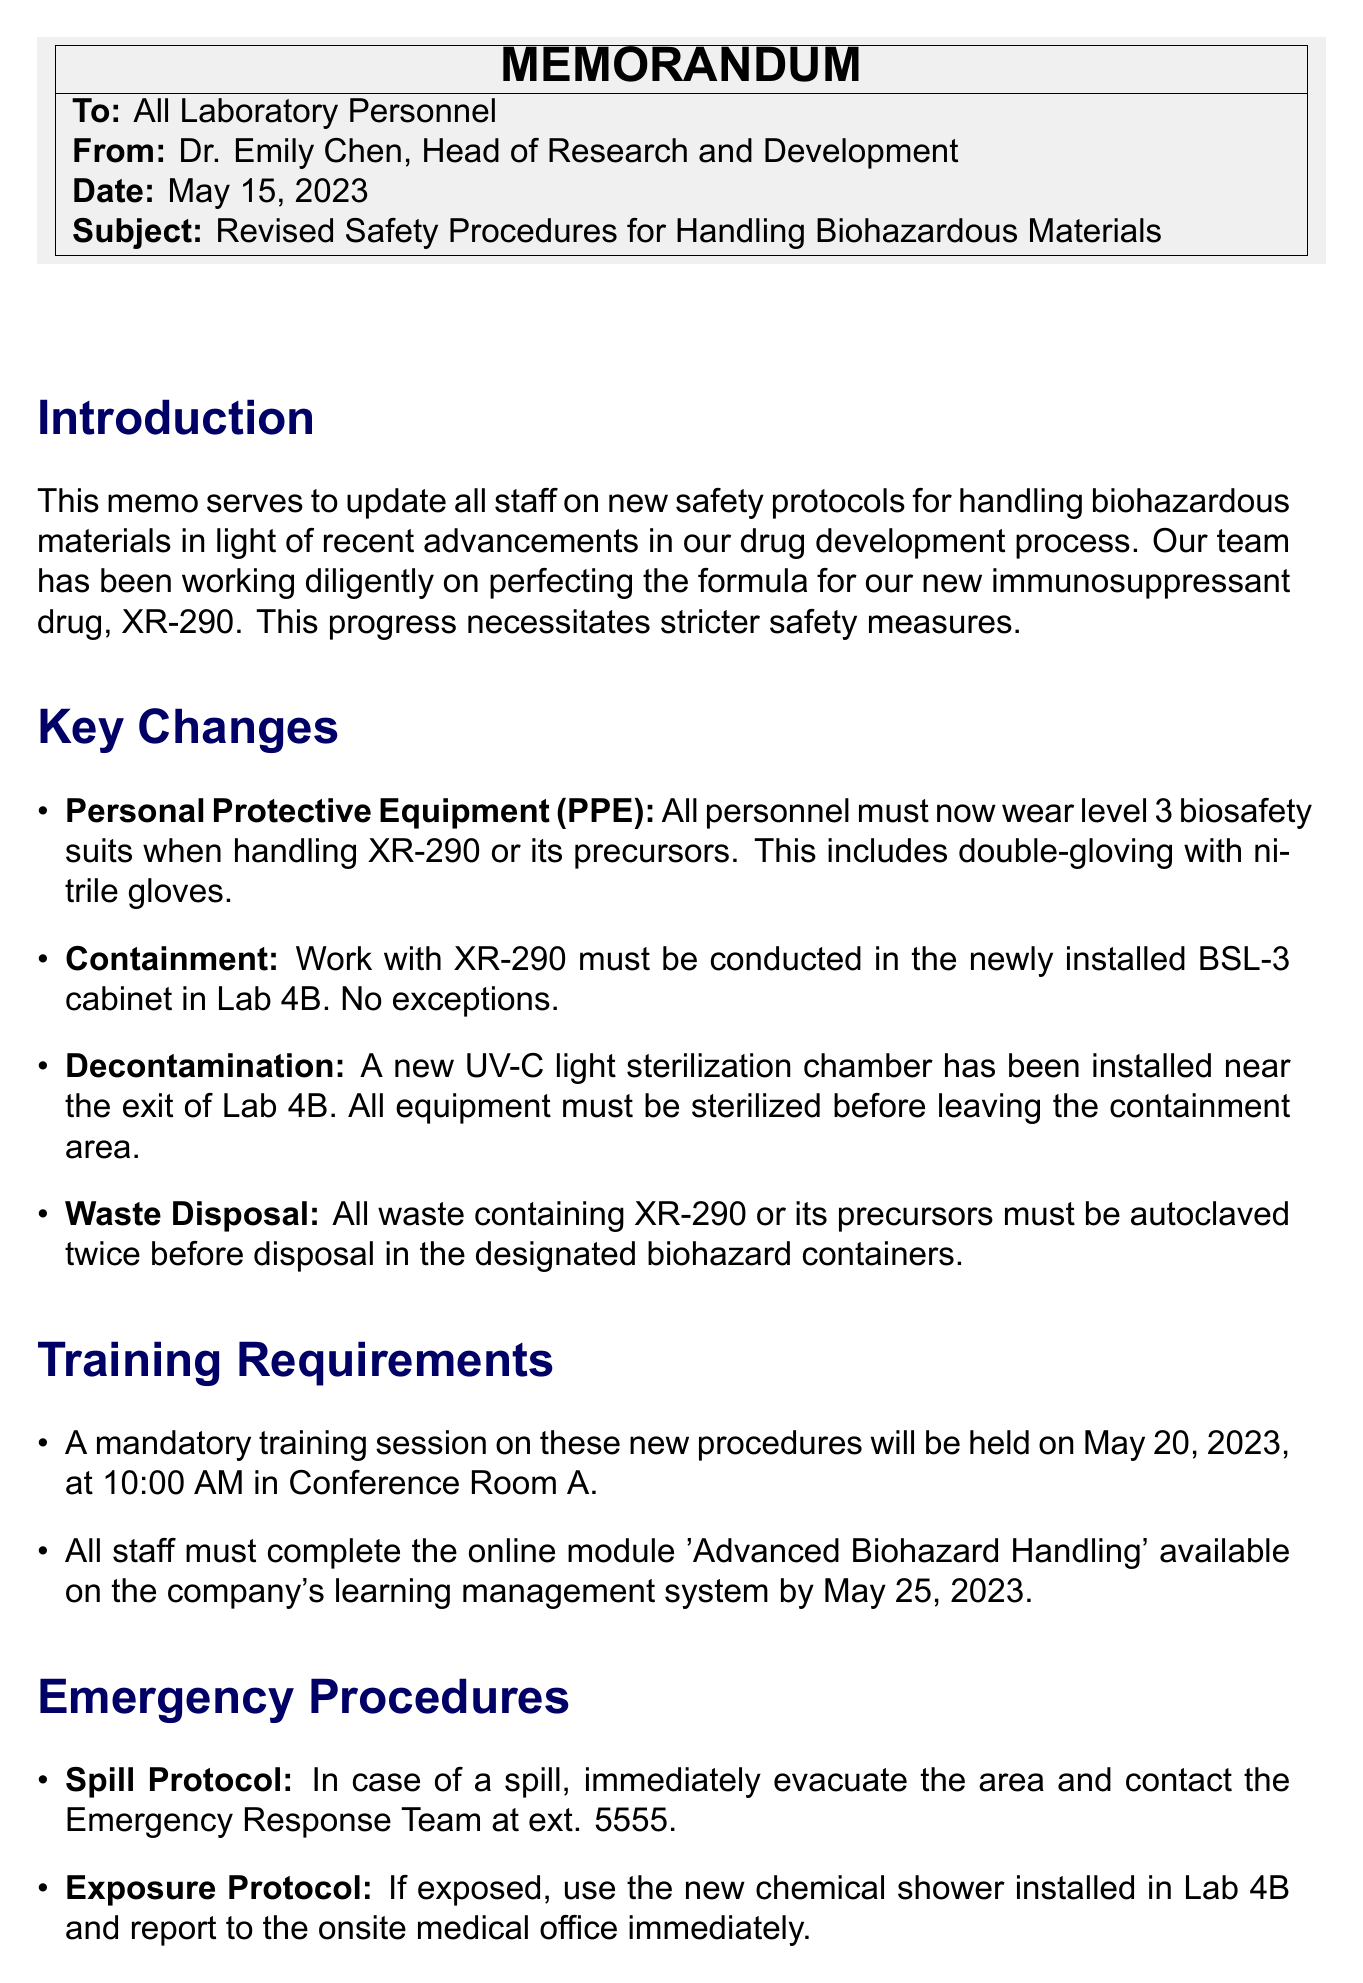What is the date of the memo? The date is explicitly stated in the header section of the memo.
Answer: May 15, 2023 Who is the author of the memo? The author is indicated in the "from" line of the header.
Answer: Dr. Emily Chen What new equipment is required for decontamination? The memo specifies the installed equipment for decontamination in the section on key changes.
Answer: UV-C light sterilization chamber When is the mandatory training session scheduled? The date and time of the training session are provided in the training requirements section.
Answer: May 20, 2023, at 10:00 AM What type of suit must personnel wear when handling XR-290? The required personal protective equipment is detailed in the key changes section of the memo.
Answer: Level 3 biosafety suits What should be done with waste containing XR-290? The waste disposal procedures are outlined in the key changes section and detail the required actions for waste management.
Answer: Autoclaved twice before disposal What action should be taken in case of a spill? The emergency procedures section defines the immediate action needed in case of a spill.
Answer: Evacuate the area and contact the Emergency Response Team What is the compliance statement about the new procedures? The compliance requirements are specified towards the end of the memo, providing information on adherence to the new guidelines.
Answer: Compliance with these new procedures is mandatory What is the purpose of the memo? The purpose is stated in the introduction section that describes the reason for updating safety protocols.
Answer: To update all staff on new safety protocols for handling biohazardous materials 